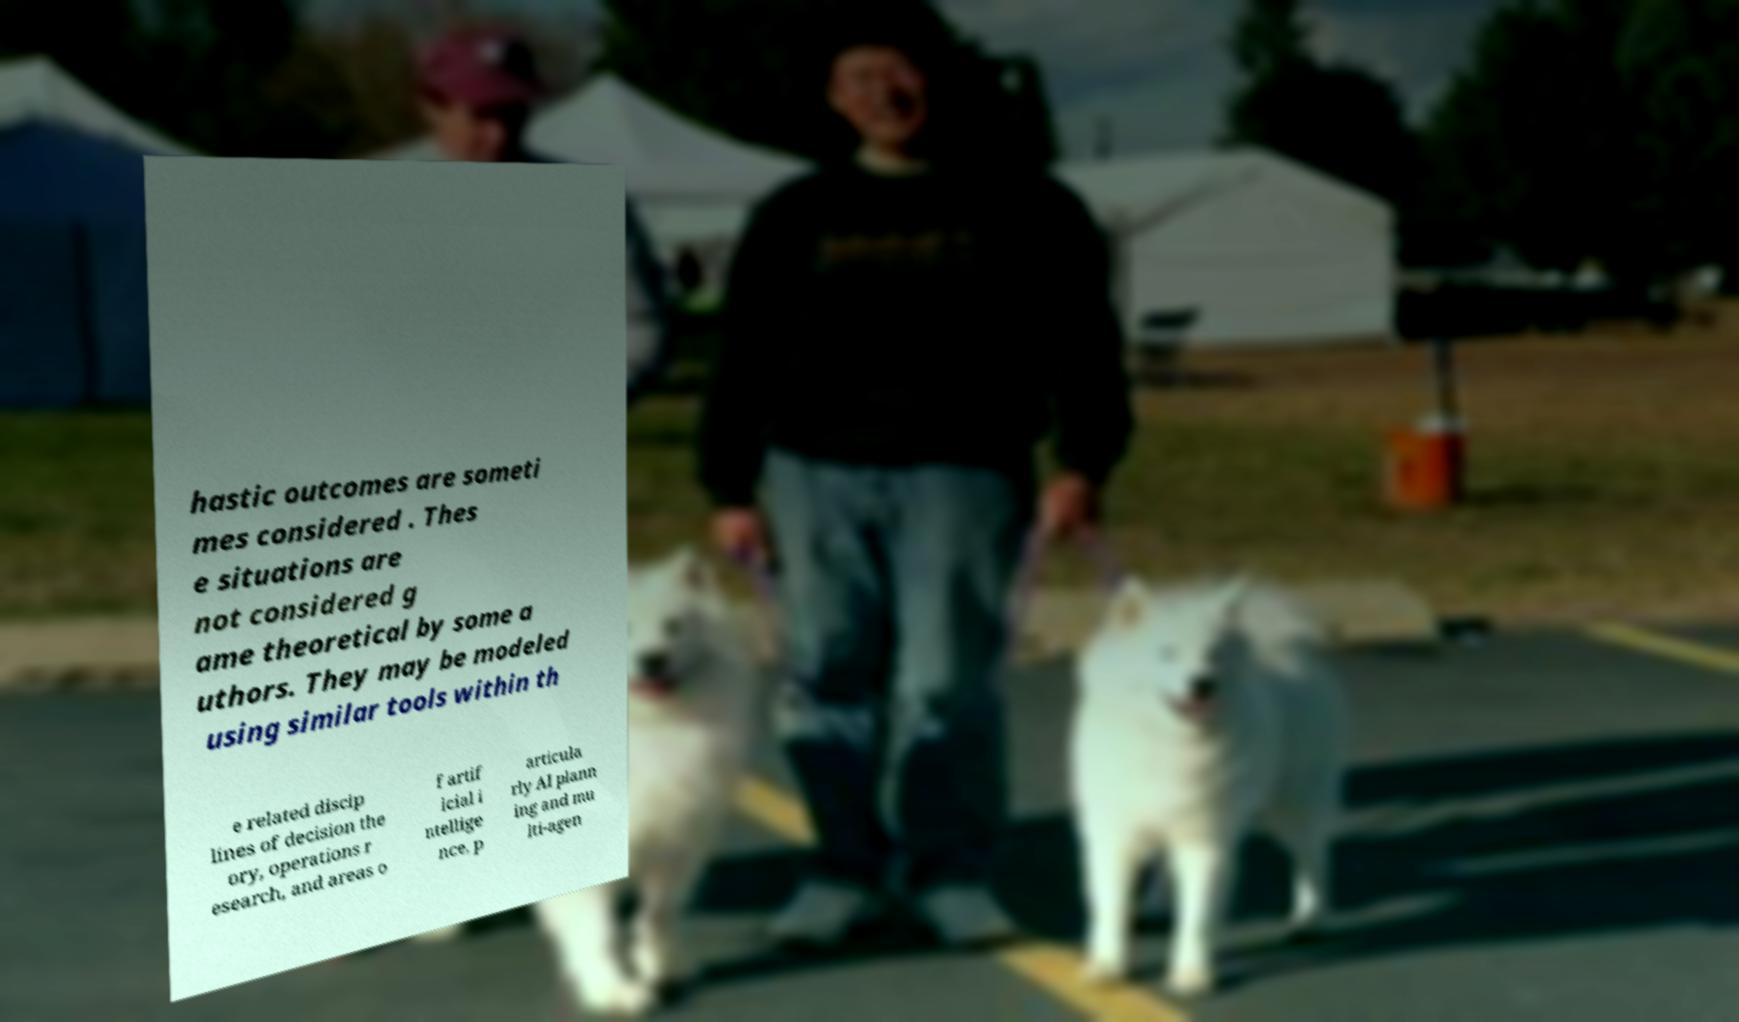Can you accurately transcribe the text from the provided image for me? hastic outcomes are someti mes considered . Thes e situations are not considered g ame theoretical by some a uthors. They may be modeled using similar tools within th e related discip lines of decision the ory, operations r esearch, and areas o f artif icial i ntellige nce, p articula rly AI plann ing and mu lti-agen 